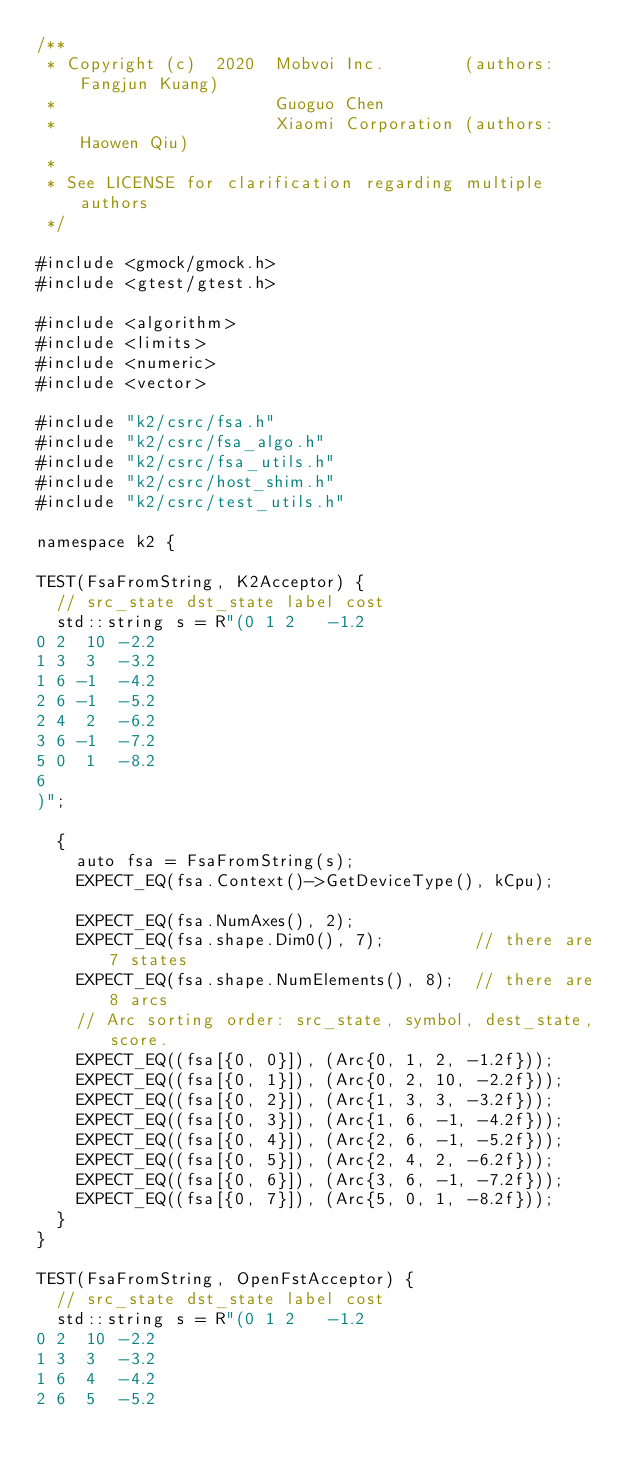Convert code to text. <code><loc_0><loc_0><loc_500><loc_500><_Cuda_>/**
 * Copyright (c)  2020  Mobvoi Inc.        (authors: Fangjun Kuang)
 *                      Guoguo Chen
 *                      Xiaomi Corporation (authors: Haowen Qiu)
 *
 * See LICENSE for clarification regarding multiple authors
 */

#include <gmock/gmock.h>
#include <gtest/gtest.h>

#include <algorithm>
#include <limits>
#include <numeric>
#include <vector>

#include "k2/csrc/fsa.h"
#include "k2/csrc/fsa_algo.h"
#include "k2/csrc/fsa_utils.h"
#include "k2/csrc/host_shim.h"
#include "k2/csrc/test_utils.h"

namespace k2 {

TEST(FsaFromString, K2Acceptor) {
  // src_state dst_state label cost
  std::string s = R"(0 1 2   -1.2
0 2  10 -2.2
1 3  3  -3.2
1 6 -1  -4.2
2 6 -1  -5.2
2 4  2  -6.2
3 6 -1  -7.2
5 0  1  -8.2
6
)";

  {
    auto fsa = FsaFromString(s);
    EXPECT_EQ(fsa.Context()->GetDeviceType(), kCpu);

    EXPECT_EQ(fsa.NumAxes(), 2);
    EXPECT_EQ(fsa.shape.Dim0(), 7);         // there are 7 states
    EXPECT_EQ(fsa.shape.NumElements(), 8);  // there are 8 arcs
    // Arc sorting order: src_state, symbol, dest_state, score.
    EXPECT_EQ((fsa[{0, 0}]), (Arc{0, 1, 2, -1.2f}));
    EXPECT_EQ((fsa[{0, 1}]), (Arc{0, 2, 10, -2.2f}));
    EXPECT_EQ((fsa[{0, 2}]), (Arc{1, 3, 3, -3.2f}));
    EXPECT_EQ((fsa[{0, 3}]), (Arc{1, 6, -1, -4.2f}));
    EXPECT_EQ((fsa[{0, 4}]), (Arc{2, 6, -1, -5.2f}));
    EXPECT_EQ((fsa[{0, 5}]), (Arc{2, 4, 2, -6.2f}));
    EXPECT_EQ((fsa[{0, 6}]), (Arc{3, 6, -1, -7.2f}));
    EXPECT_EQ((fsa[{0, 7}]), (Arc{5, 0, 1, -8.2f}));
  }
}

TEST(FsaFromString, OpenFstAcceptor) {
  // src_state dst_state label cost
  std::string s = R"(0 1 2   -1.2
0 2  10 -2.2
1 3  3  -3.2
1 6  4  -4.2
2 6  5  -5.2</code> 